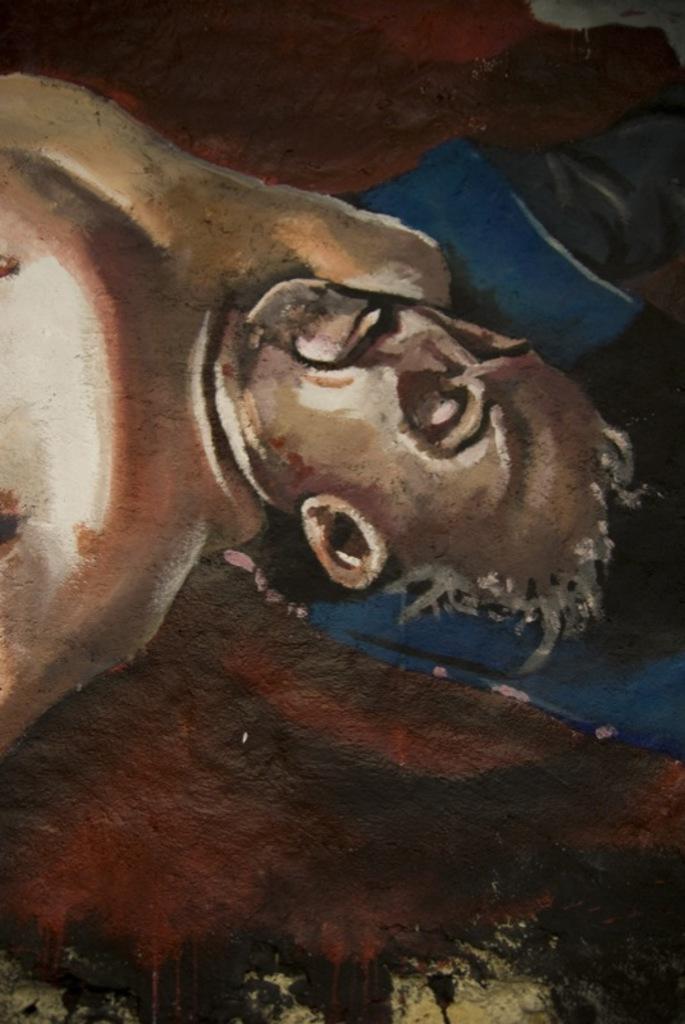Describe this image in one or two sentences. In this image we can see a painting. There is a painting of a person and few other objects in the image. 